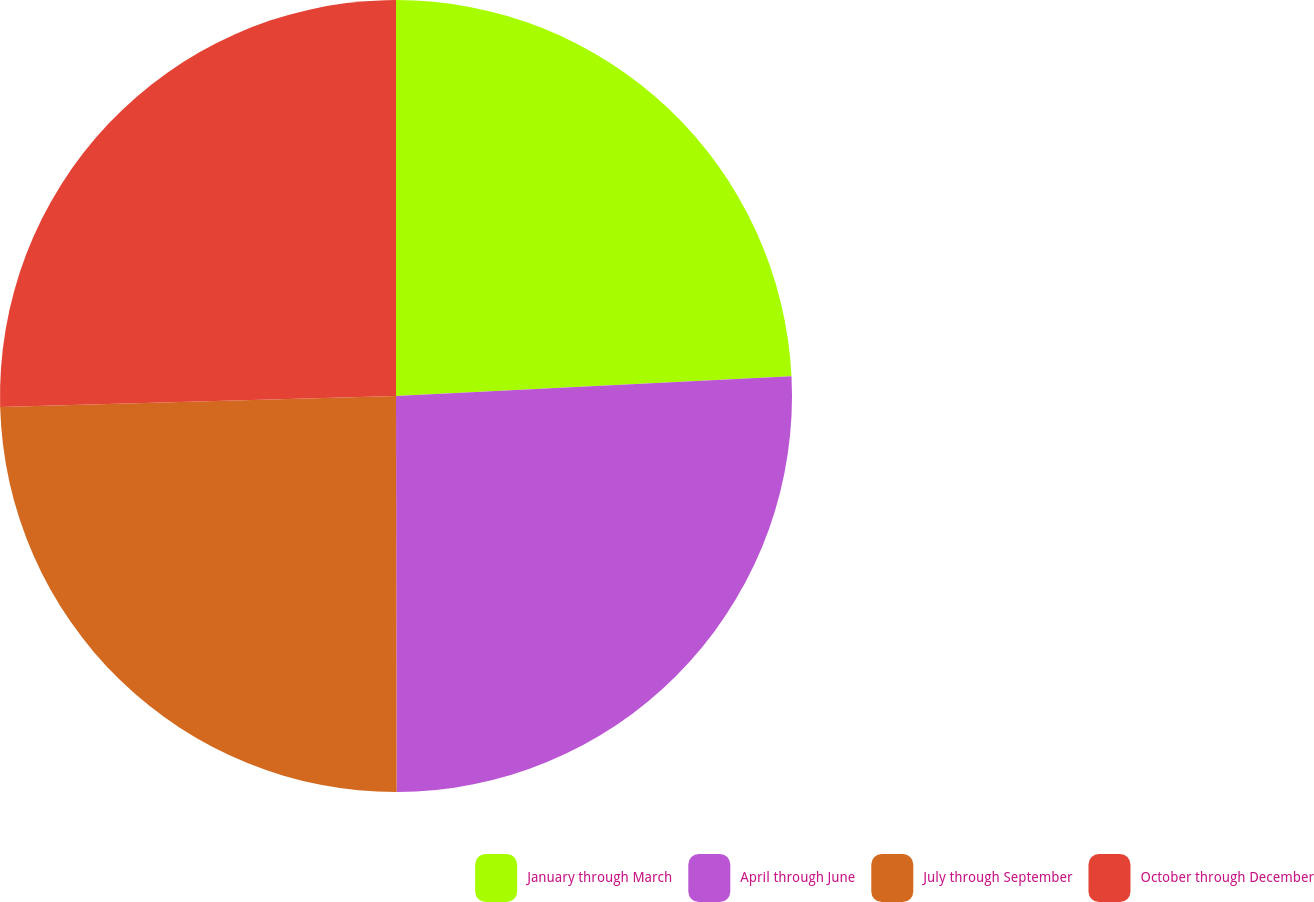<chart> <loc_0><loc_0><loc_500><loc_500><pie_chart><fcel>January through March<fcel>April through June<fcel>July through September<fcel>October through December<nl><fcel>24.21%<fcel>25.77%<fcel>24.59%<fcel>25.44%<nl></chart> 